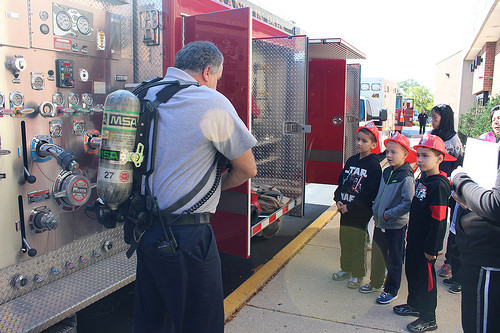<image>
Can you confirm if the boy is to the left of the boy? Yes. From this viewpoint, the boy is positioned to the left side relative to the boy. Is there a boy to the left of the man? No. The boy is not to the left of the man. From this viewpoint, they have a different horizontal relationship. Is there a boy behind the woman? No. The boy is not behind the woman. From this viewpoint, the boy appears to be positioned elsewhere in the scene. 